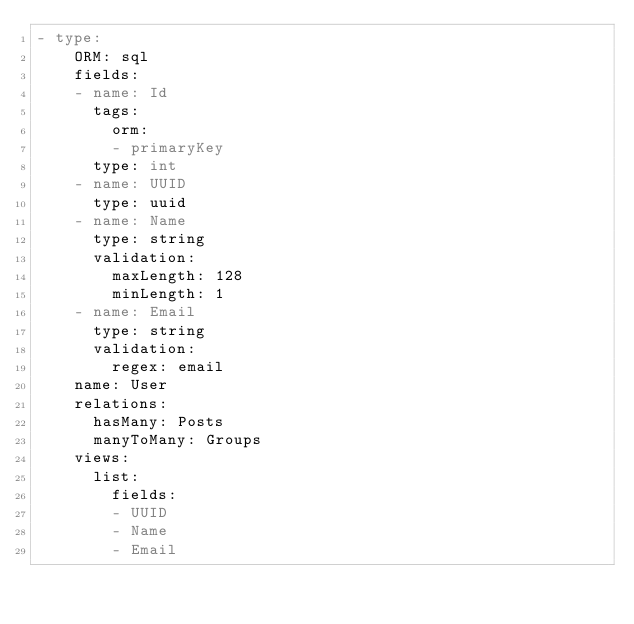Convert code to text. <code><loc_0><loc_0><loc_500><loc_500><_YAML_>- type:
    ORM: sql
    fields:
    - name: Id
      tags:
        orm:
        - primaryKey
      type: int
    - name: UUID
      type: uuid
    - name: Name
      type: string
      validation:
        maxLength: 128
        minLength: 1
    - name: Email
      type: string
      validation:
        regex: email
    name: User
    relations:
      hasMany: Posts
      manyToMany: Groups
    views:
      list:
        fields:
        - UUID
        - Name
        - Email

</code> 